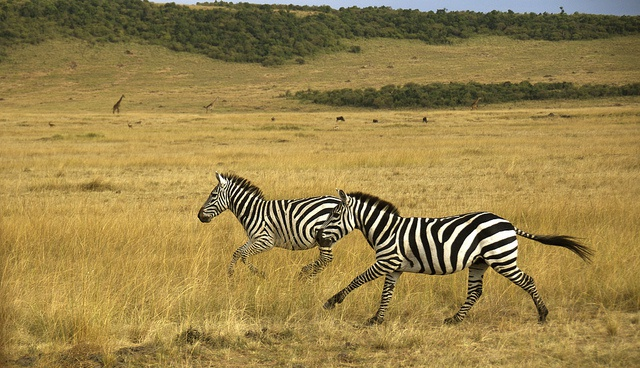Describe the objects in this image and their specific colors. I can see zebra in olive, black, tan, and beige tones, zebra in olive, black, tan, and khaki tones, giraffe in olive and maroon tones, giraffe in olive and tan tones, and giraffe in olive and black tones in this image. 